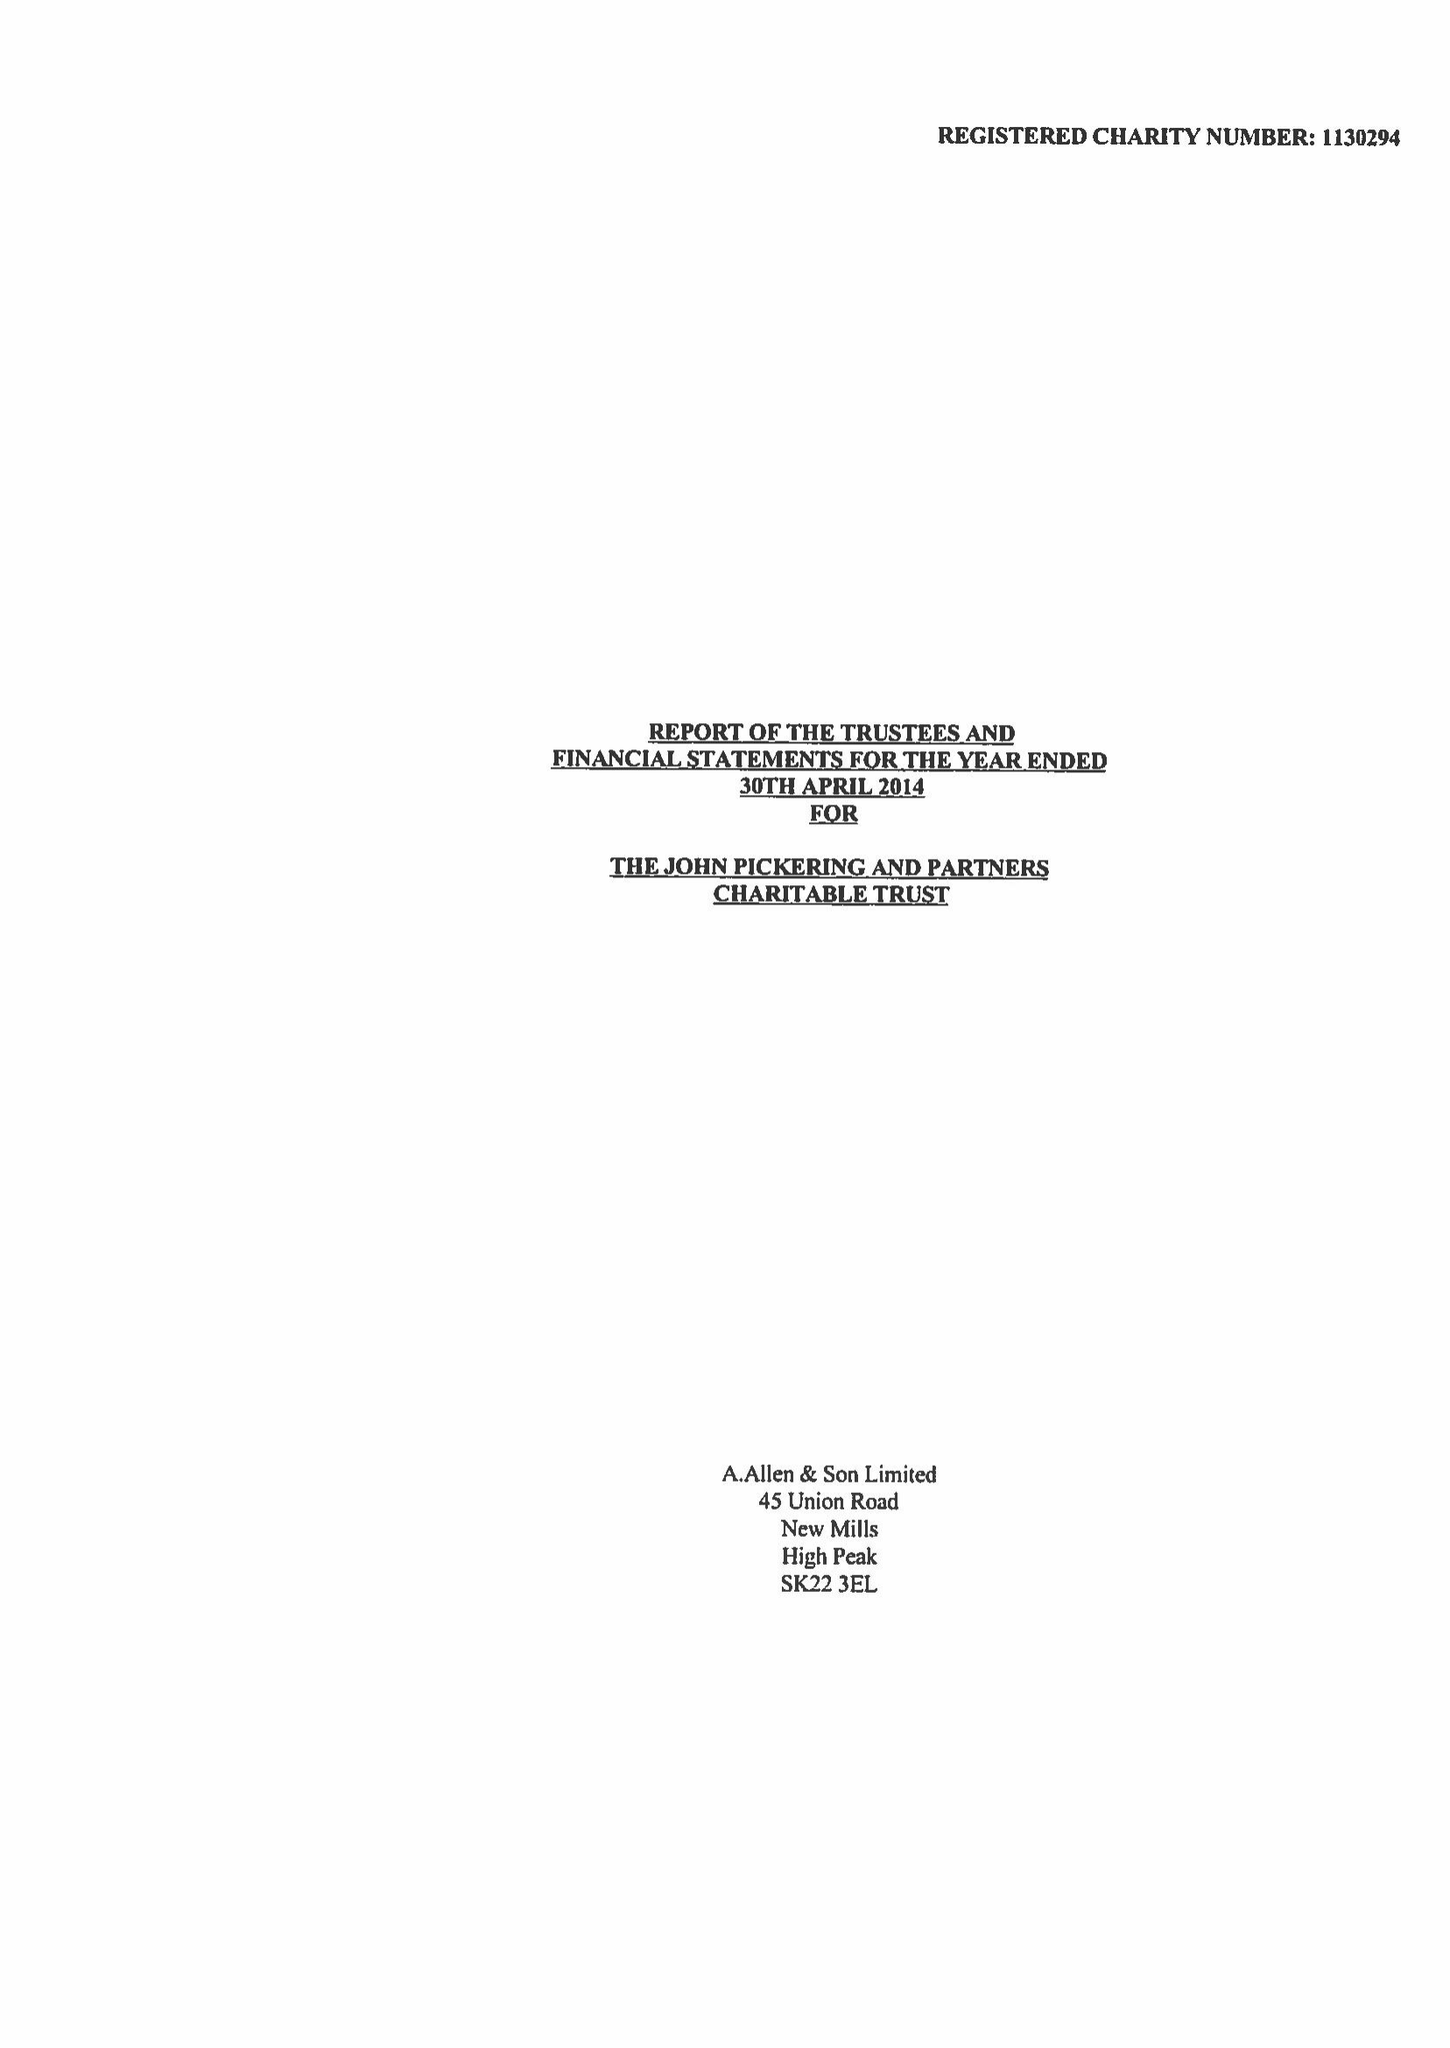What is the value for the charity_number?
Answer the question using a single word or phrase. 1130294 